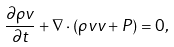Convert formula to latex. <formula><loc_0><loc_0><loc_500><loc_500>\frac { \partial \rho { v } } { \partial t } + { \nabla } \cdot ( \rho { v v } + P ) = 0 ,</formula> 